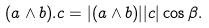<formula> <loc_0><loc_0><loc_500><loc_500>( { a } \wedge { b } ) . { c } = | ( { a } \wedge { b } ) | | { c } | \cos \beta .</formula> 